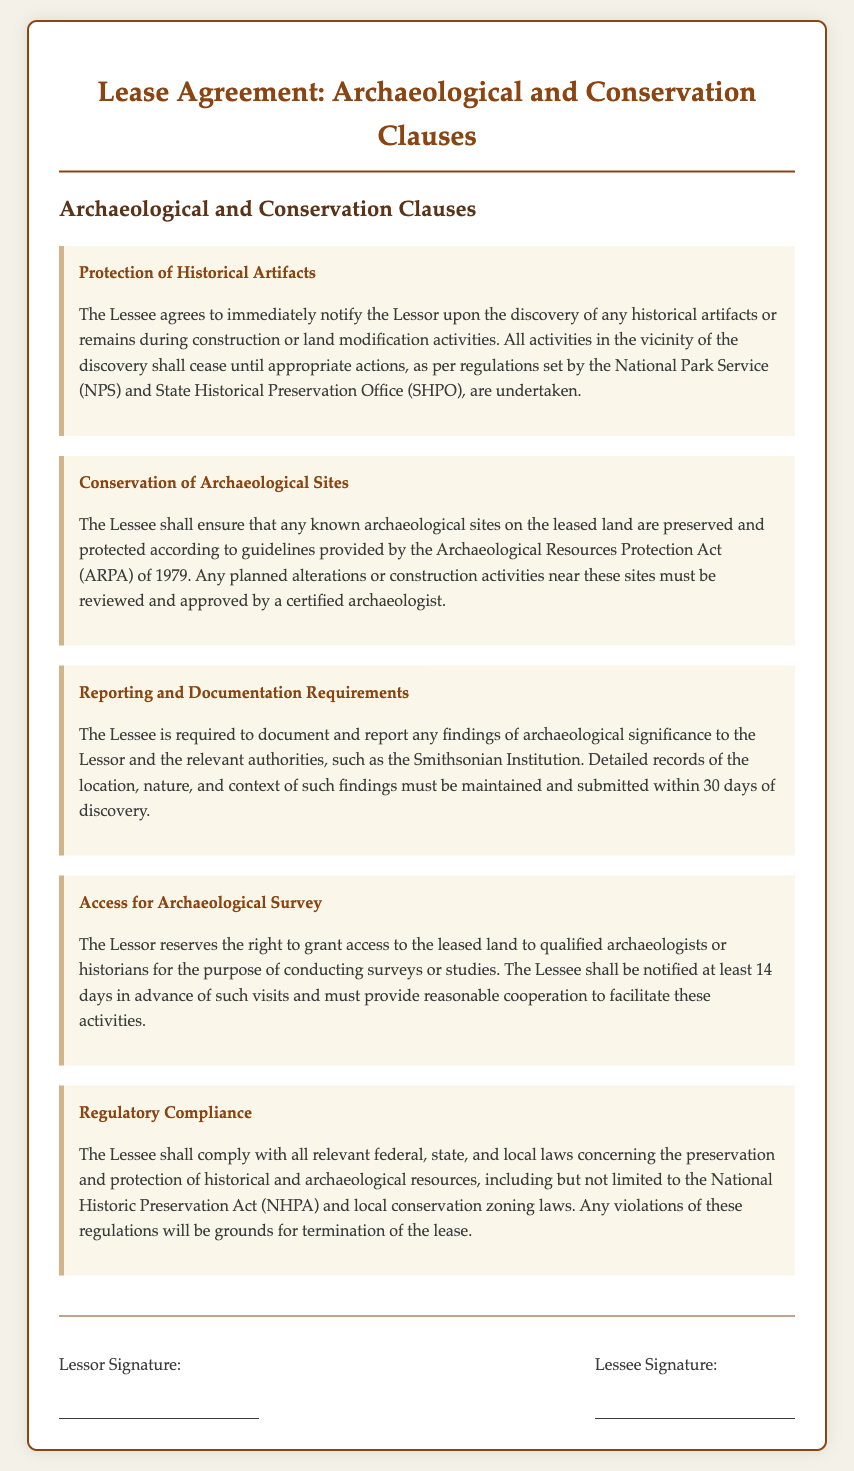What does the Lessee need to do upon discovering historical artifacts? The Lessee is required to immediately notify the Lessor upon the discovery of any historical artifacts or remains.
Answer: Notify the Lessor What act provides guidelines for the preservation of archaeological sites? The guidelines for the preservation of archaeological sites are provided by the Archaeological Resources Protection Act (ARPA) of 1979.
Answer: Archaeological Resources Protection Act What is required from the Lessee within 30 days of an archaeological finding? The Lessee must document and report any findings of archaeological significance within 30 days of discovery.
Answer: 30 days How much notice must the Lessor give before granting access for a survey? The Lessor must notify the Lessee at least 14 days in advance before such visits for conducting surveys or studies.
Answer: 14 days What grounds could lead to the termination of the lease? Violations of the regulations concerning preservation and protection of historical and archaeological resources can lead to lease termination.
Answer: Violations of regulations What is the main purpose of the "Access for Archaeological Survey" clause? The purpose is to grant access to qualified archaeologists or historians for conducting surveys or studies on the leased land.
Answer: Grant access What must be maintained according to the Reporting and Documentation Requirements? The Lessee must maintain detailed records of the location, nature, and context of archaeological findings.
Answer: Detailed records Who should the Lessee report archaeological findings to? The Lessee is required to report findings to the Lessor and the relevant authorities.
Answer: Lessor and relevant authorities 